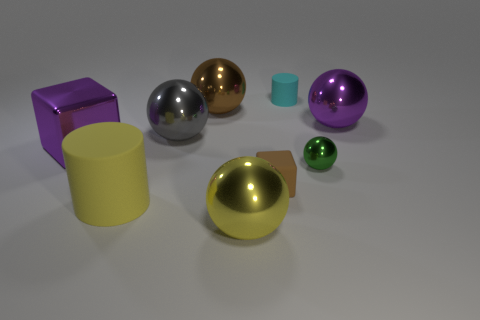Subtract 2 spheres. How many spheres are left? 3 Subtract all gray spheres. How many spheres are left? 4 Subtract all cyan spheres. Subtract all purple cubes. How many spheres are left? 5 Add 1 yellow cylinders. How many objects exist? 10 Subtract all cylinders. How many objects are left? 7 Subtract 1 cyan cylinders. How many objects are left? 8 Subtract all tiny yellow rubber blocks. Subtract all small cyan rubber objects. How many objects are left? 8 Add 5 small green objects. How many small green objects are left? 6 Add 5 cyan rubber objects. How many cyan rubber objects exist? 6 